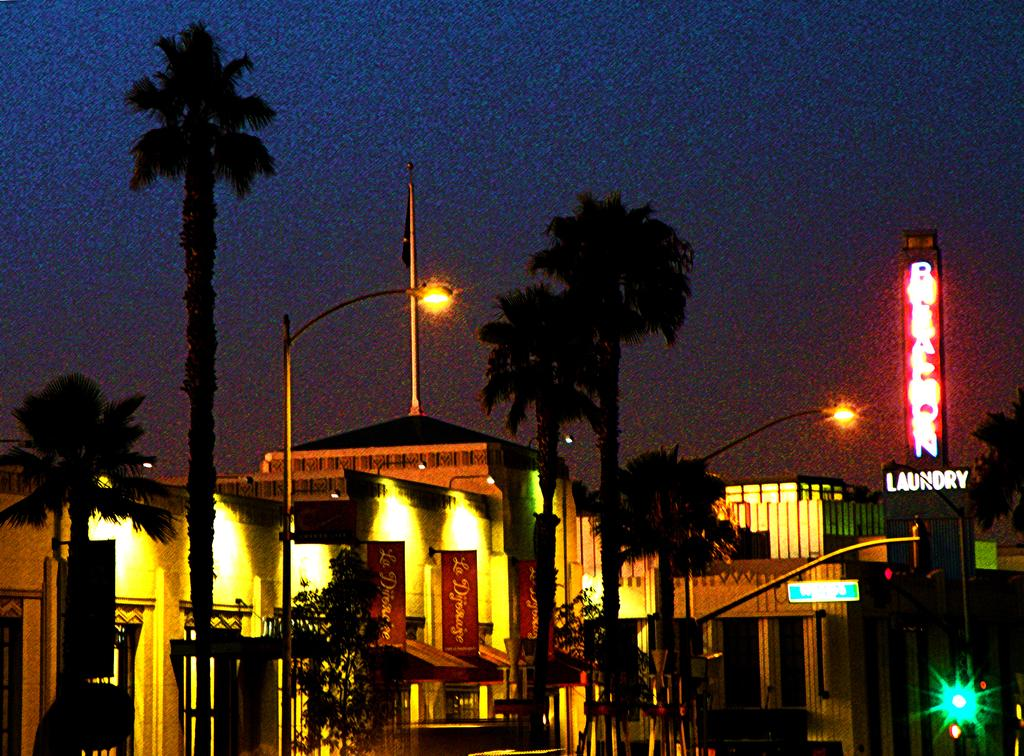What type of structures can be seen in the image? There are buildings in the image. What are the tall, vertical objects in the image? There are light poles in the image. What is the flat, rectangular object in the image? There is a board in the image. What type of text is visible on the board? There is LED text in the image. What type of vegetation is present in the image? There are plants in the image. What type of text can be seen in the image, besides the LED text? There is text in the image. How would you describe the sky in the image? The sky is dark in the image. What flavor of ice cream is being advertised on the board in the image? There is no ice cream or advertisement present in the image. How many people are driving in the image? There are no vehicles or people driving in the image. 